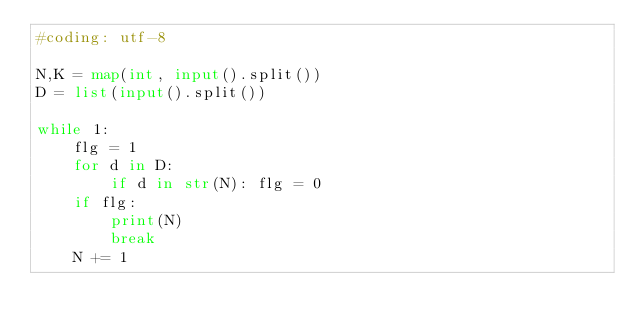<code> <loc_0><loc_0><loc_500><loc_500><_Python_>#coding: utf-8

N,K = map(int, input().split())
D = list(input().split())

while 1:
    flg = 1
    for d in D:
        if d in str(N): flg = 0
    if flg:
        print(N)
        break
    N += 1</code> 